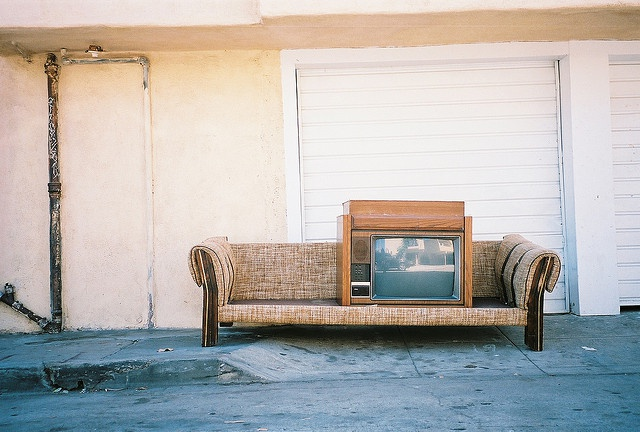Describe the objects in this image and their specific colors. I can see couch in lightgray, tan, black, and gray tones and tv in lightgray, darkgray, teal, and gray tones in this image. 